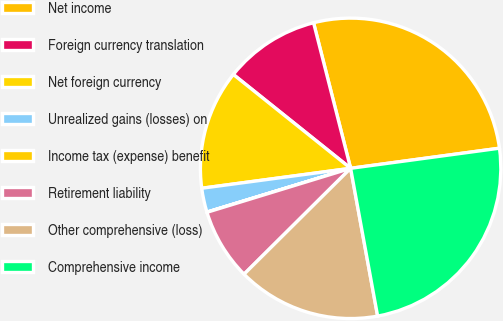Convert chart to OTSL. <chart><loc_0><loc_0><loc_500><loc_500><pie_chart><fcel>Net income<fcel>Foreign currency translation<fcel>Net foreign currency<fcel>Unrealized gains (losses) on<fcel>Income tax (expense) benefit<fcel>Retirement liability<fcel>Other comprehensive (loss)<fcel>Comprehensive income<nl><fcel>26.83%<fcel>10.29%<fcel>12.86%<fcel>2.59%<fcel>0.02%<fcel>7.72%<fcel>15.43%<fcel>24.26%<nl></chart> 